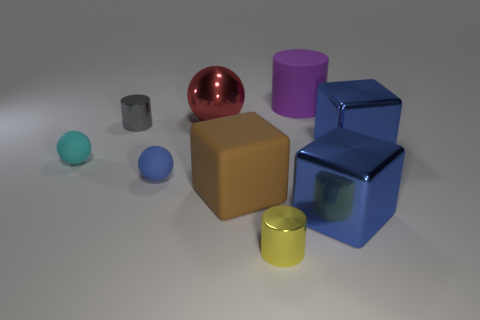The rubber object that is both behind the tiny blue matte thing and to the right of the small gray metallic object has what shape?
Make the answer very short. Cylinder. How many other objects are the same shape as the gray metal thing?
Make the answer very short. 2. Are there more brown rubber cubes on the right side of the large red shiny object than red matte cubes?
Your response must be concise. Yes. There is a purple thing that is the same shape as the yellow object; what size is it?
Keep it short and to the point. Large. What is the shape of the red object?
Your response must be concise. Sphere. What is the shape of the gray thing that is the same size as the blue sphere?
Your response must be concise. Cylinder. There is a red thing that is the same material as the yellow cylinder; what size is it?
Provide a succinct answer. Large. Does the blue matte object have the same shape as the red object right of the tiny cyan rubber object?
Offer a terse response. Yes. How big is the yellow cylinder?
Offer a terse response. Small. Is the number of big cylinders in front of the small cyan thing less than the number of yellow metal cylinders?
Make the answer very short. Yes. 